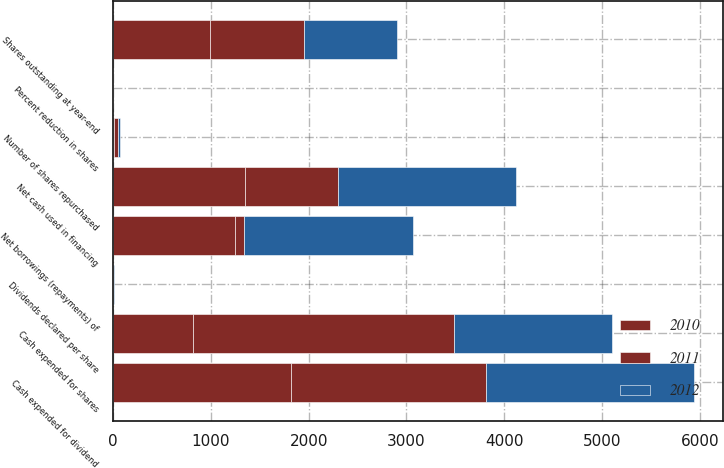Convert chart to OTSL. <chart><loc_0><loc_0><loc_500><loc_500><stacked_bar_chart><ecel><fcel>Net cash used in financing<fcel>Cash expended for shares<fcel>Number of shares repurchased<fcel>Shares outstanding at year-end<fcel>Percent reduction in shares<fcel>Dividends declared per share<fcel>Cash expended for dividend<fcel>Net borrowings (repayments) of<nl><fcel>2012<fcel>1817<fcel>1621<fcel>21.8<fcel>953<fcel>1<fcel>2.28<fcel>2130<fcel>1729<nl><fcel>2011<fcel>953<fcel>2665<fcel>38.7<fcel>963<fcel>2.8<fcel>2.08<fcel>1997<fcel>95<nl><fcel>2010<fcel>1346<fcel>817<fcel>12.4<fcel>991<fcel>0.3<fcel>1.88<fcel>1818<fcel>1246<nl></chart> 